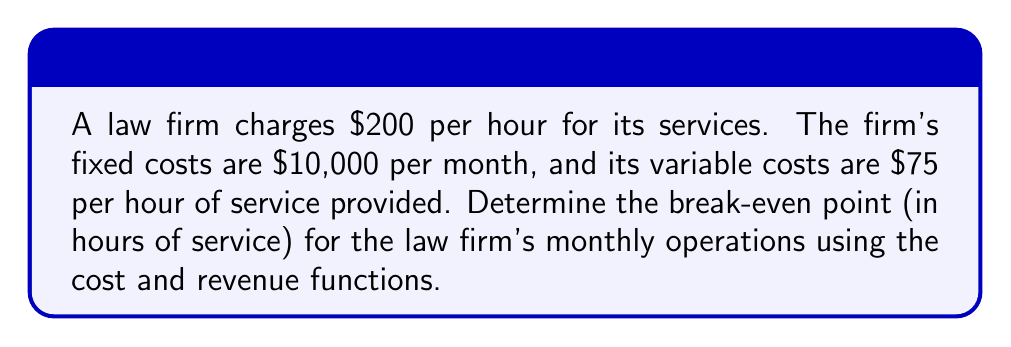Can you solve this math problem? Let's approach this step-by-step:

1) First, we need to define our variables:
   Let $x$ = number of hours of service provided per month

2) Now, let's set up our revenue function:
   Revenue (R) = Price per hour × Number of hours
   $R = 200x$

3) Next, let's set up our cost function:
   Cost (C) = Fixed costs + (Variable cost per hour × Number of hours)
   $C = 10000 + 75x$

4) The break-even point occurs when Revenue equals Cost:
   $R = C$
   $200x = 10000 + 75x$

5) Let's solve this equation:
   $200x - 75x = 10000$
   $125x = 10000$

6) Divide both sides by 125:
   $x = \frac{10000}{125} = 80$

Therefore, the law firm needs to provide 80 hours of service per month to break even.
Answer: 80 hours 